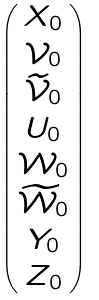Convert formula to latex. <formula><loc_0><loc_0><loc_500><loc_500>\begin{pmatrix} X _ { 0 } \\ \mathcal { V } _ { 0 } \\ \widetilde { \mathcal { V } } _ { 0 } \\ U _ { 0 } \\ \mathcal { W } _ { 0 } \\ \widetilde { \mathcal { W } } _ { 0 } \\ Y _ { 0 } \\ Z _ { 0 } \end{pmatrix}</formula> 